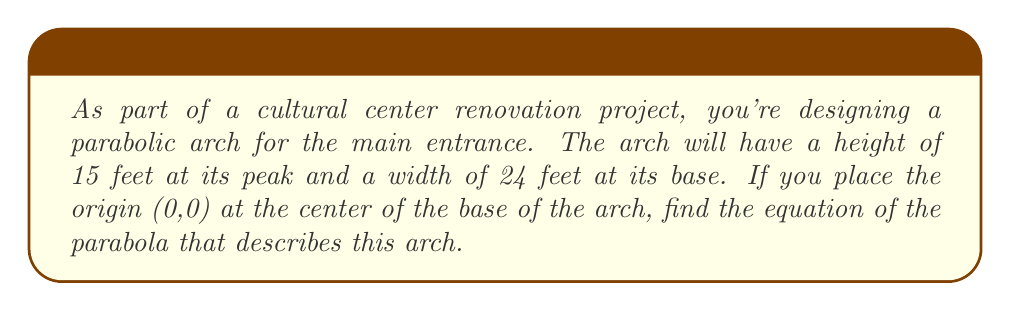Give your solution to this math problem. Let's approach this step-by-step:

1) The general form of a parabola with a vertical axis of symmetry is:

   $$ y = a(x - h)^2 + k $$

   where (h, k) is the vertex of the parabola.

2) In this case, the vertex is at the top center of the arch. We know:
   - The width is 24 feet, so the x-coordinates of the base points are -12 and 12.
   - The height is 15 feet, so the y-coordinate of the vertex is 15.

   Therefore, the vertex is at (0, 15).

3) Substituting h = 0 and k = 15 into our general form:

   $$ y = ax^2 + 15 $$

4) To find a, we can use the point (12, 0), which is where the arch meets the ground:

   $$ 0 = a(12)^2 + 15 $$
   $$ -15 = 144a $$
   $$ a = -\frac{15}{144} = -\frac{5}{48} $$

5) Therefore, the equation of the parabola is:

   $$ y = -\frac{5}{48}x^2 + 15 $$

6) To verify, we can check if this equation satisfies the other base point (-12, 0):

   $$ 0 = -\frac{5}{48}(-12)^2 + 15 $$
   $$ 0 = -\frac{5}{48}(144) + 15 $$
   $$ 0 = -15 + 15 $$
   $$ 0 = 0 $$

   This confirms our equation is correct.
Answer: $$ y = -\frac{5}{48}x^2 + 15 $$ 